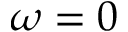Convert formula to latex. <formula><loc_0><loc_0><loc_500><loc_500>\omega = 0</formula> 